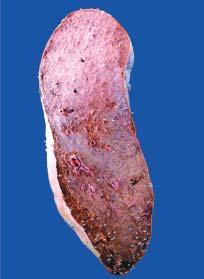s the vesselwall heavy and enlarged in size?
Answer the question using a single word or phrase. No 